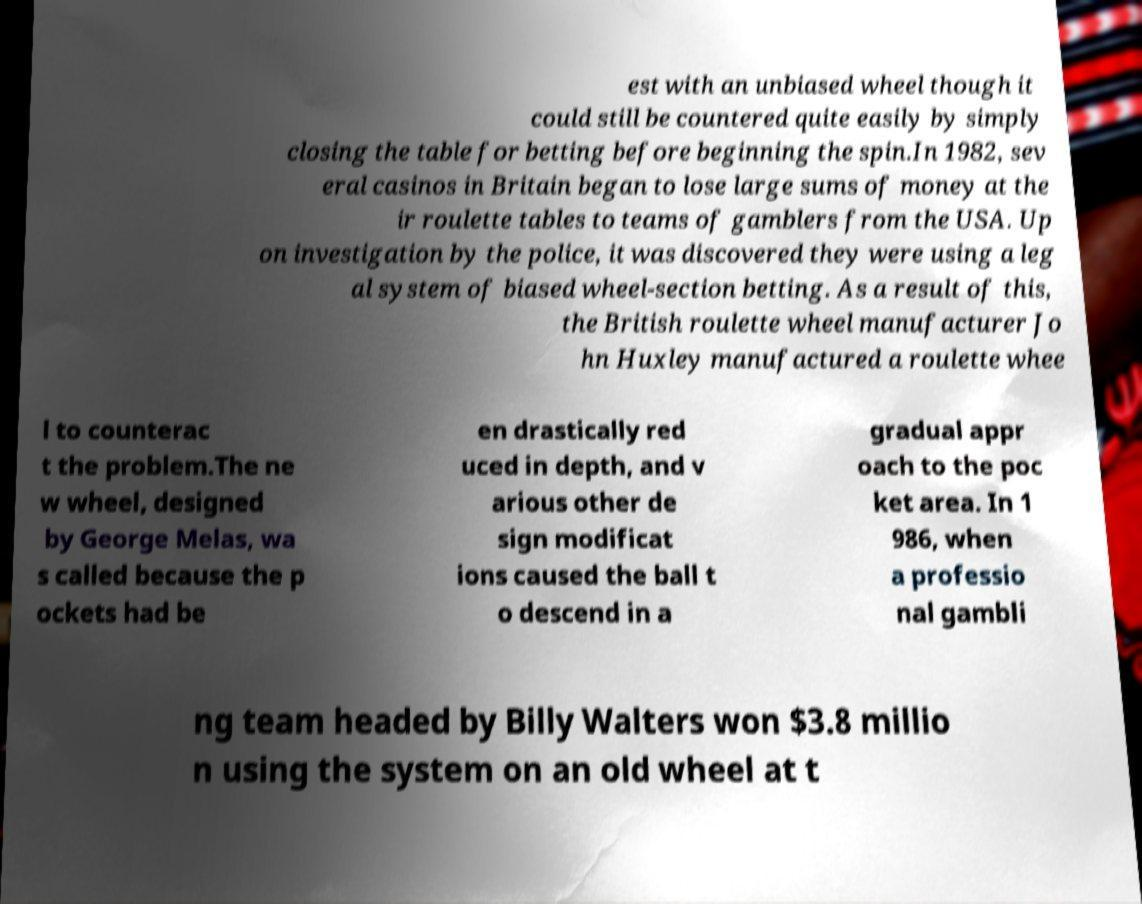For documentation purposes, I need the text within this image transcribed. Could you provide that? est with an unbiased wheel though it could still be countered quite easily by simply closing the table for betting before beginning the spin.In 1982, sev eral casinos in Britain began to lose large sums of money at the ir roulette tables to teams of gamblers from the USA. Up on investigation by the police, it was discovered they were using a leg al system of biased wheel-section betting. As a result of this, the British roulette wheel manufacturer Jo hn Huxley manufactured a roulette whee l to counterac t the problem.The ne w wheel, designed by George Melas, wa s called because the p ockets had be en drastically red uced in depth, and v arious other de sign modificat ions caused the ball t o descend in a gradual appr oach to the poc ket area. In 1 986, when a professio nal gambli ng team headed by Billy Walters won $3.8 millio n using the system on an old wheel at t 